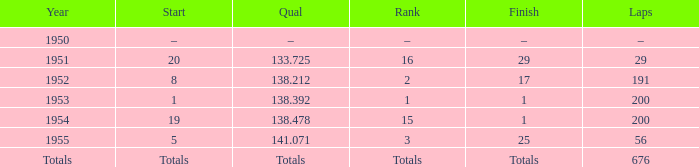What finish achieved at 14 25.0. 